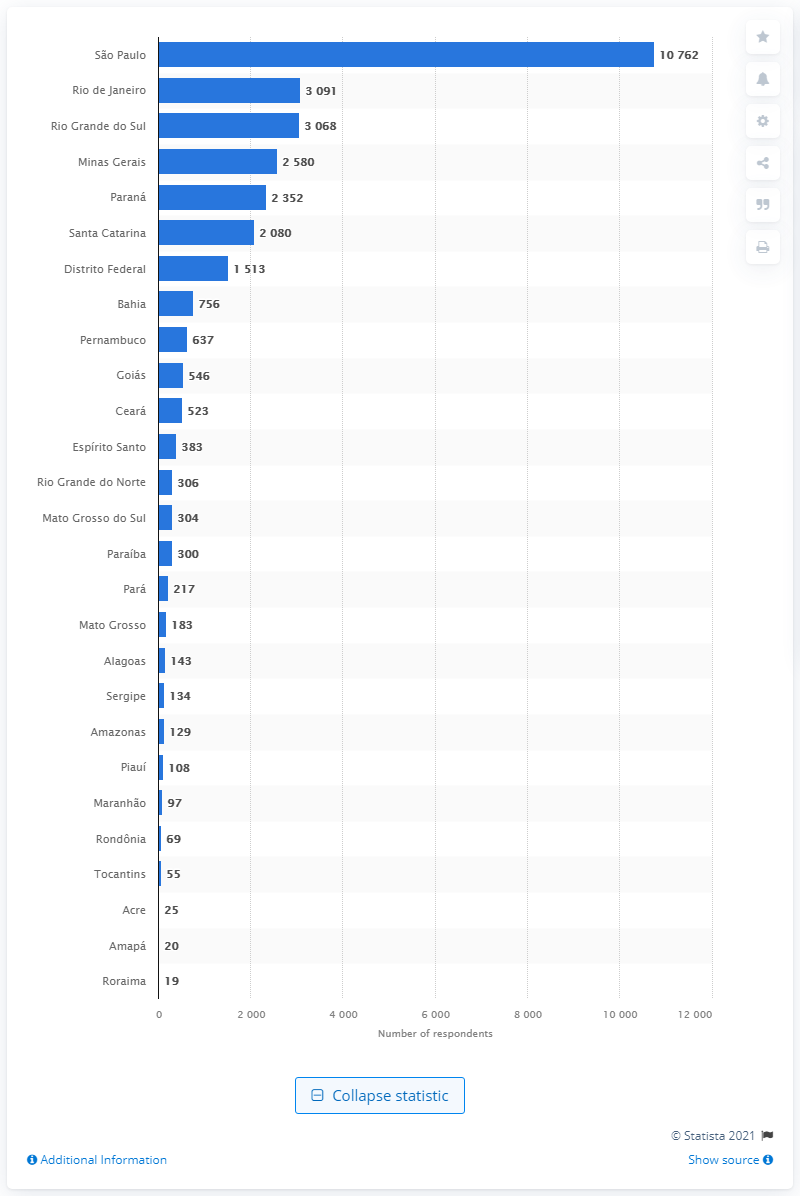Mention a couple of crucial points in this snapshot. The second largest population of self-identified vegetarians, vegans, and supporters was found in Rio de Janeiro. It is estimated that approximately 10,762 people reside in the city of S£o Paulo. 